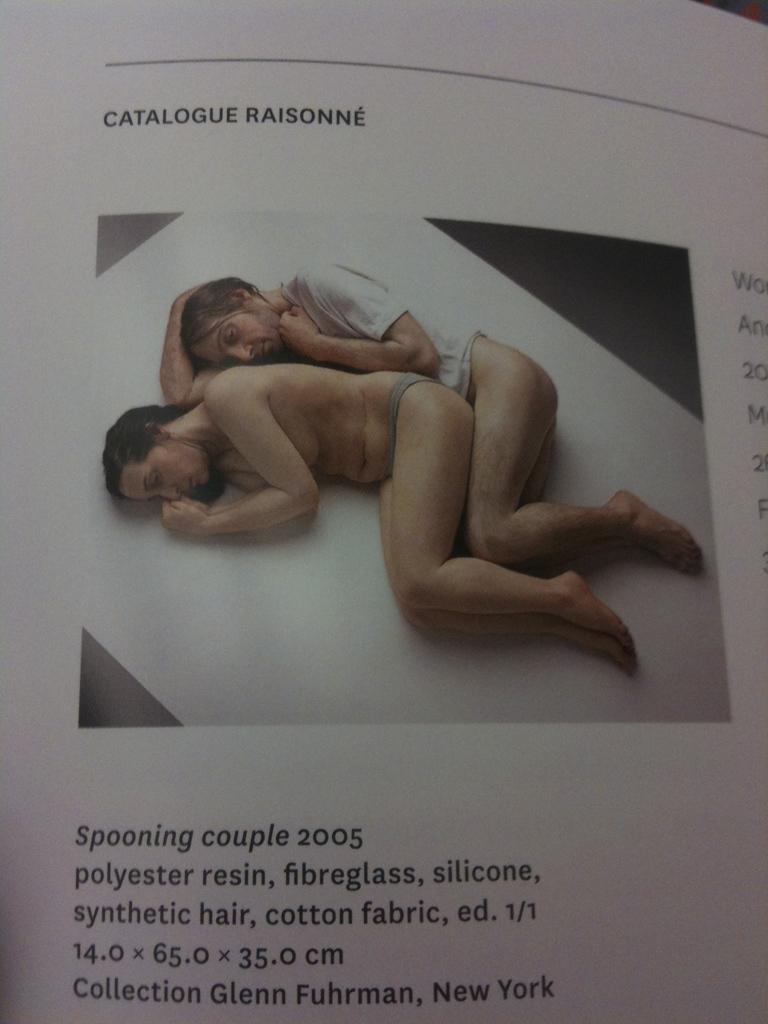Please provide a concise description of this image. In this image I can see a paper on which I can see few words written with black color and a picture. In the picture I can see two persons are sleeping on the white colored surface. 